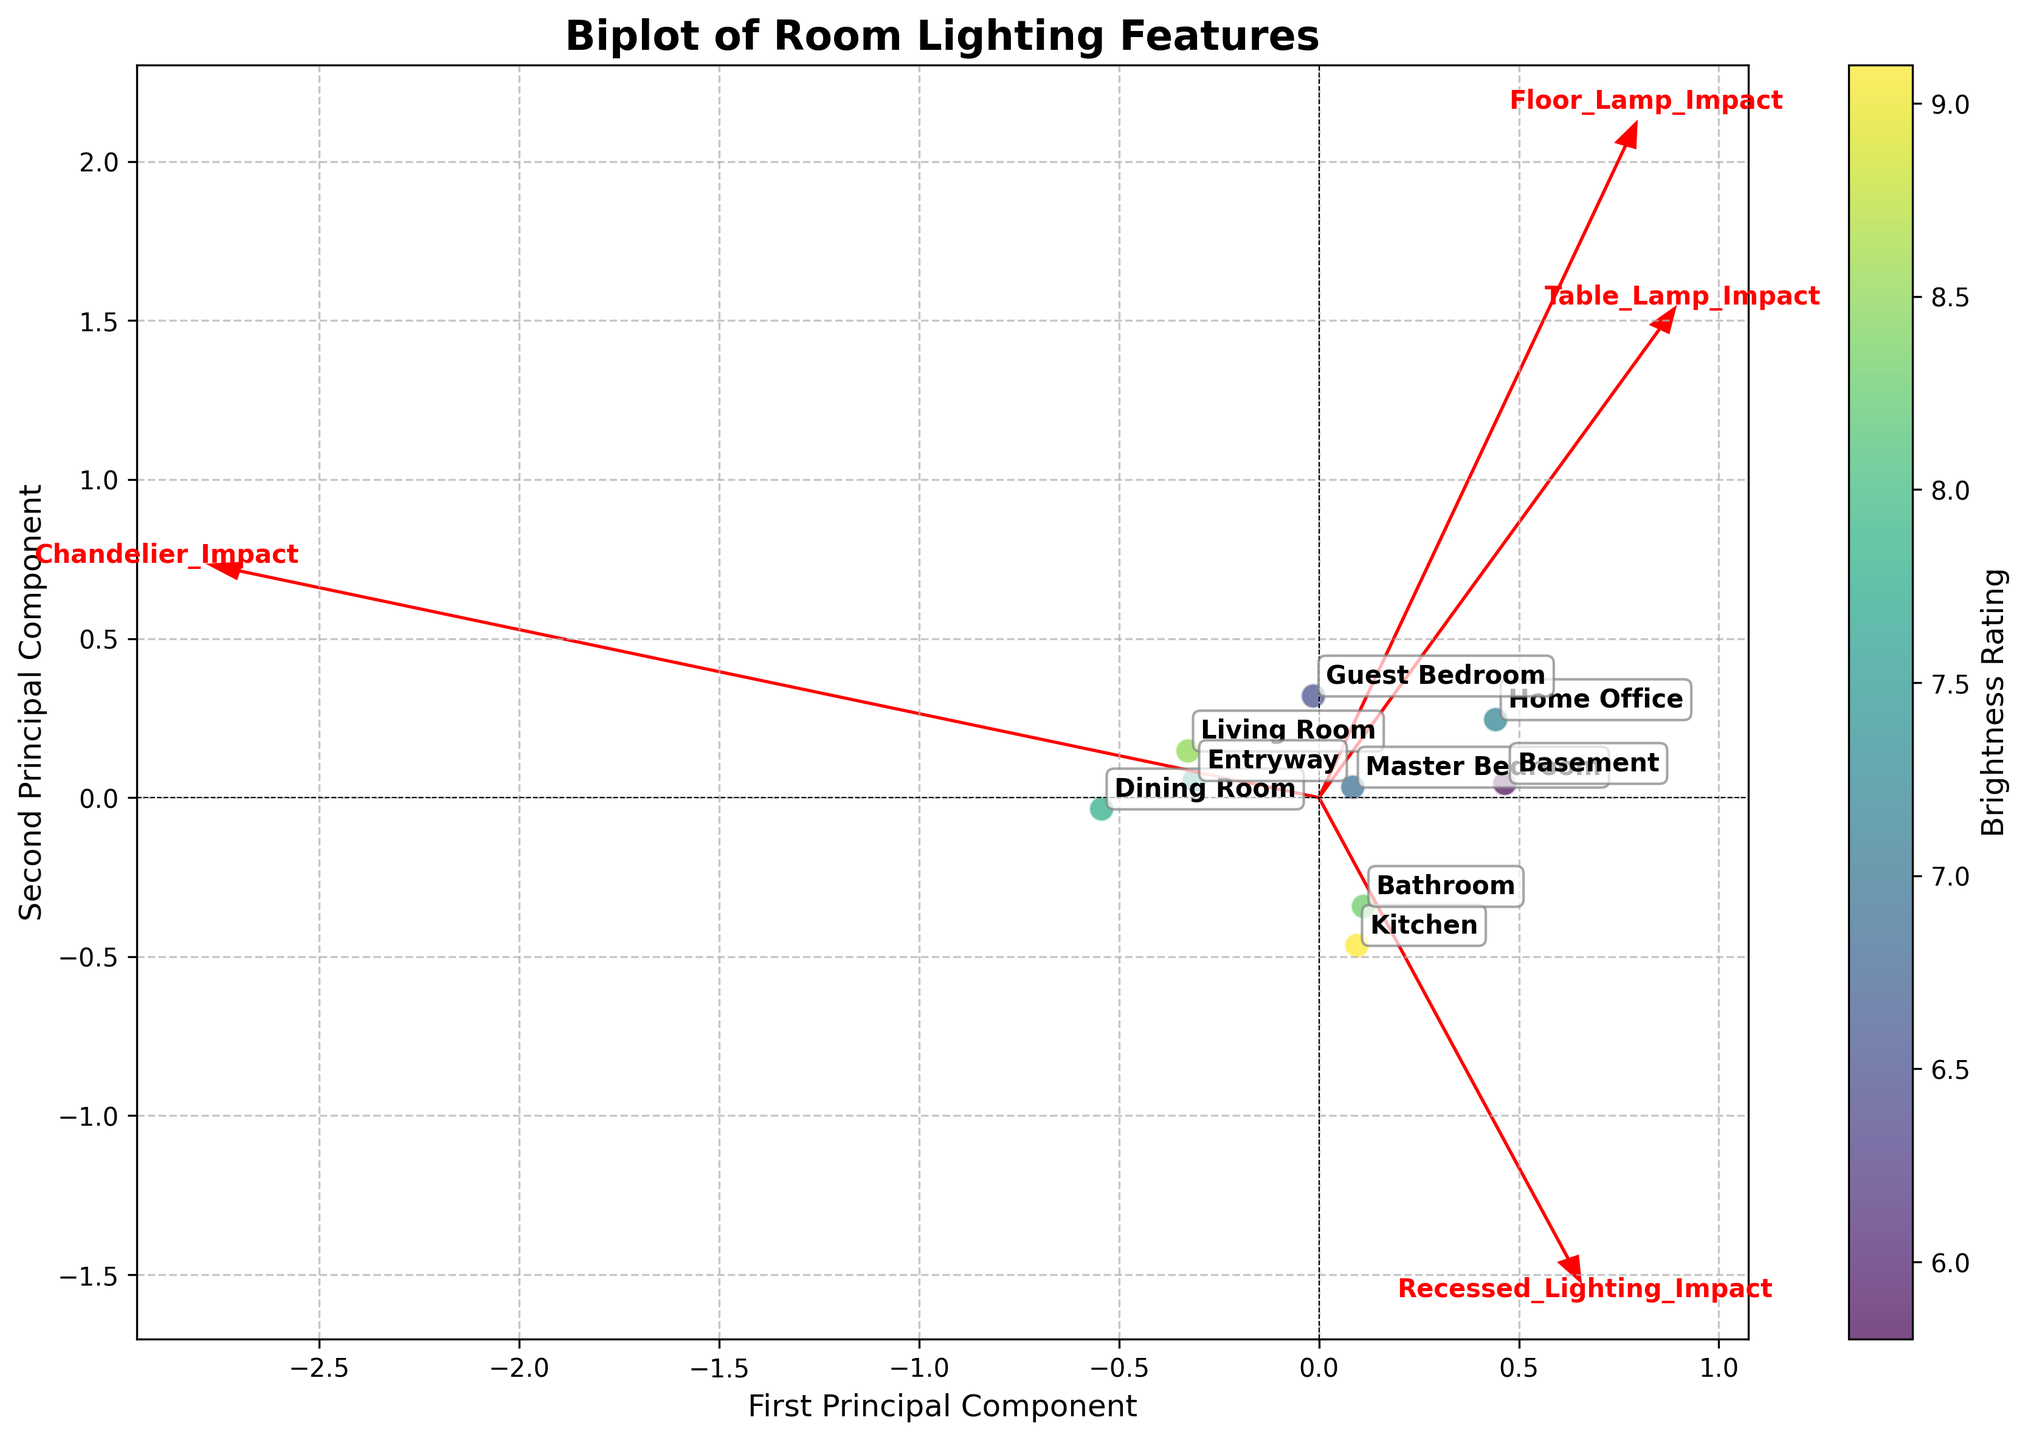What does the title of the figure say? The title of a figure is usually located at the top and helps to understand what the plot is about. By looking at the plot, we can see the title that summarizes the content.
Answer: Biplot of Room Lighting Features How many rooms are represented in the plot? To find the number of rooms, we need to count the distinct data points in the scatter plot. Each room is represented by a point.
Answer: 9 What do the arrow vectors represent? The arrow vectors are used to represent the direction and influence of each lighting feature on the principal components. The labels at the ends of the arrows help identify which feature each arrow represents.
Answer: Each lighting feature Which room has the highest brightness rating? The color of the data points is used to indicate the brightness rating, with a color bar showing the range. By identifying the room with the most intense (brightest) color, we find the room with the highest brightness rating.
Answer: Kitchen Which two lighting features seem to have the most impact on the first principal component? The first principal component is represented by the horizontal axis. By looking at the arrows, those that are aligned most closely with the horizontal axis have the most impact on the first principal component. The length of the arrows indicates the magnitude of the impact.
Answer: Recessed Lighting and Chandelier Between the Living Room and Guest Bedroom, which one shows a higher impact from Table Lamp? To determine the room with a higher impact from the Table Lamp, we need to look at the position of these two rooms relative to the arrow pointing in the direction of Table Lamp. The room that is closer to the direction of the Table Lamp arrow has a higher impact.
Answer: Guest Bedroom Does the Master Bedroom have more influence from Recessed Lighting or Floor Lamp? To determine this, we need to see the position of the Master Bedroom point relative to the arrows indicating Recessed Lighting and Floor Lamp. The feature whose vector aligns more closely with the Master Bedroom position shows greater influence.
Answer: Recessed Lighting Is the impact of Chandelier higher generally associated with rooms that have a higher or lower brightness rating? By observing the plot, we can infer the general trend by examining whether rooms closer to the direction of the Chandelier arrow have higher or lower brightness colors.
Answer: Higher brightness rating What does the second principal component represent in terms of lighting features? The second principal component is represented by the vertical axis. By observing the arrows, we identify which features align most closely with the vertical axis, indicating their contribution to the second principal component.
Answer: Floor Lamp and Table Lamp Comparing Home Office and Basement, which one has a higher brightness rating and what lighting feature impacts this difference the most? To determine which room has a higher brightness rating, we compare the colors of these two points. Next, to find which lighting feature impacts this difference the most, we look at the direction and length of arrows closest to these points.
Answer: Home Office, Table Lamp 